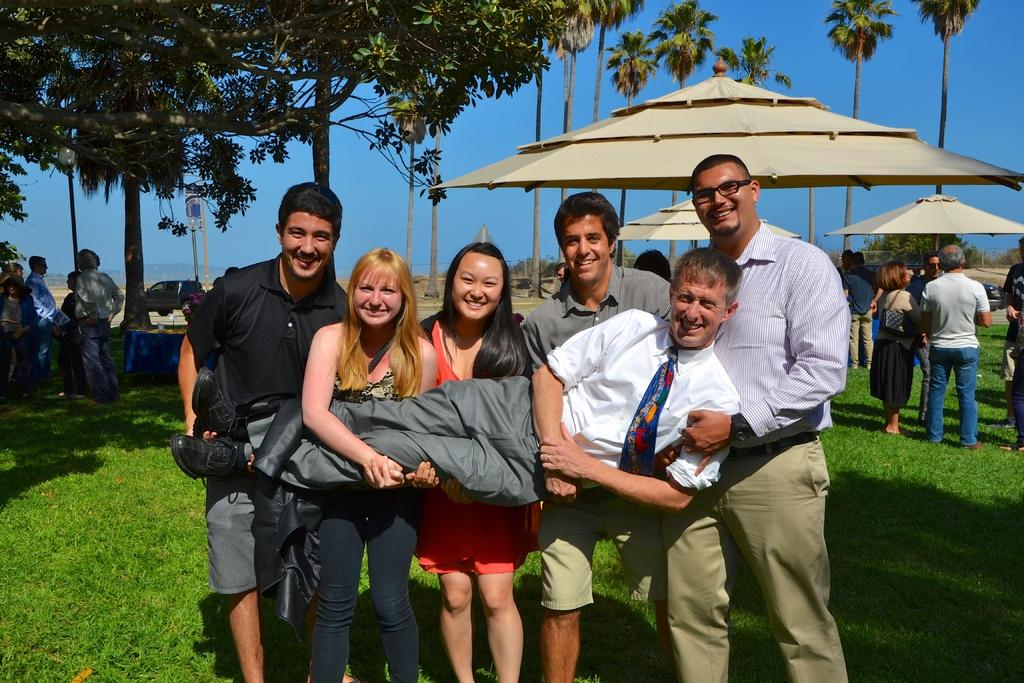How many people are standing together in the image? There are five persons standing on a greenery ground in the image. What are the people holding in their hands? The persons are holding another person in their hands. What can be seen in the background of the image? There are umbrellas, people, and trees in the background. What type of creature is hiding behind the trees in the image? There is no creature visible behind the trees in the image. What color is the powder that the people are using in the image? There is no powder present in the image. 